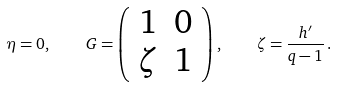Convert formula to latex. <formula><loc_0><loc_0><loc_500><loc_500>\eta = 0 , \quad G = \left ( \begin{array} { c c } 1 & 0 \\ \zeta & 1 \end{array} \right ) , \quad \zeta = \frac { h ^ { \prime } } { q - 1 } \, .</formula> 